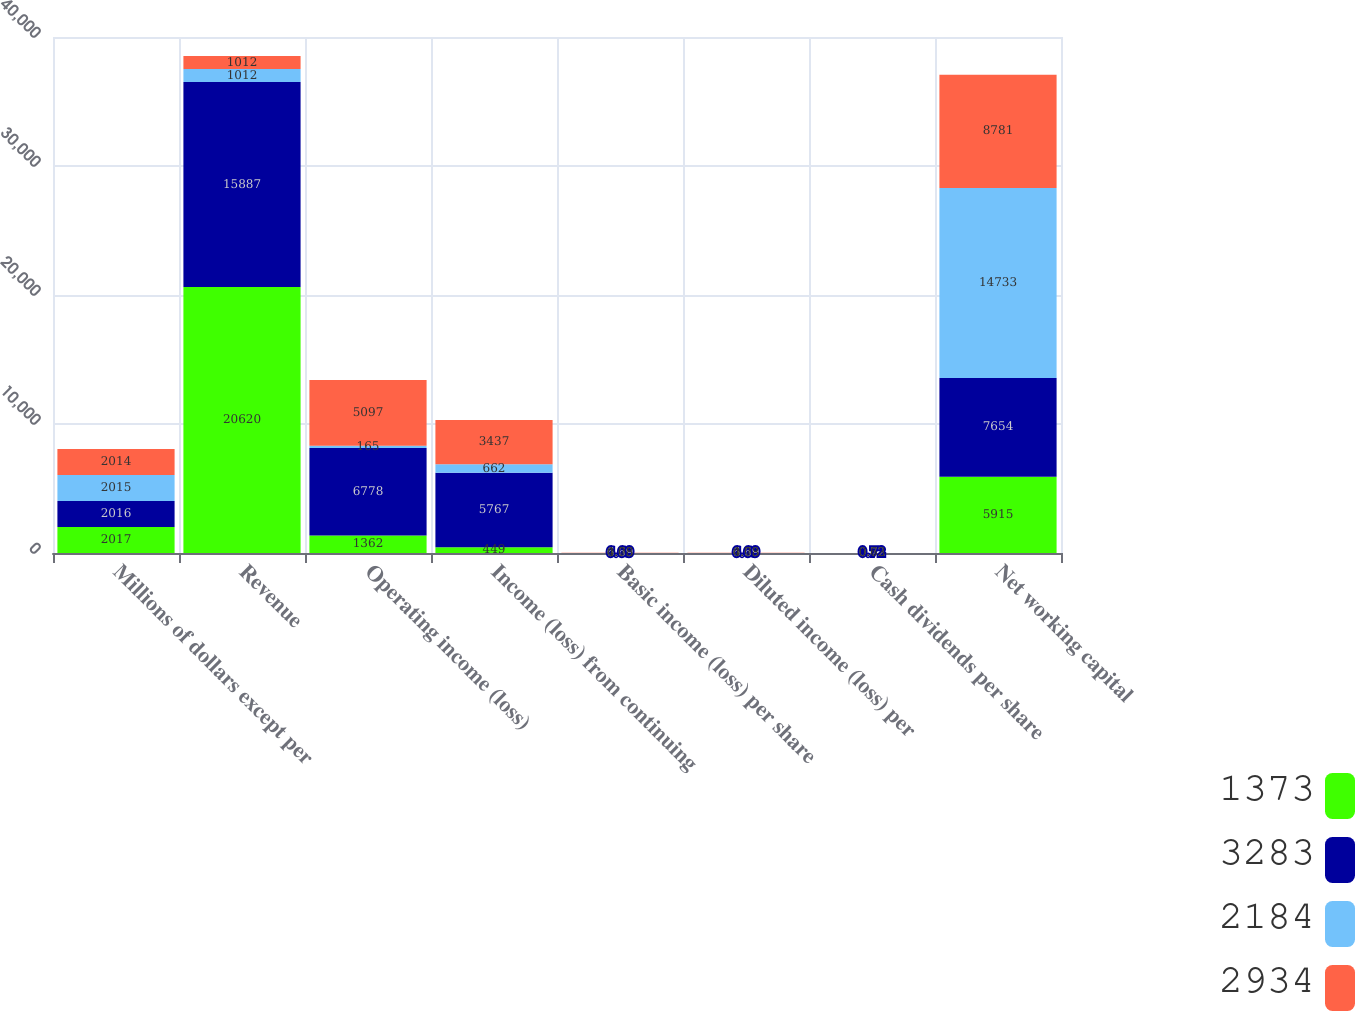<chart> <loc_0><loc_0><loc_500><loc_500><stacked_bar_chart><ecel><fcel>Millions of dollars except per<fcel>Revenue<fcel>Operating income (loss)<fcel>Income (loss) from continuing<fcel>Basic income (loss) per share<fcel>Diluted income (loss) per<fcel>Cash dividends per share<fcel>Net working capital<nl><fcel>1373<fcel>2017<fcel>20620<fcel>1362<fcel>449<fcel>0.51<fcel>0.51<fcel>0.72<fcel>5915<nl><fcel>3283<fcel>2016<fcel>15887<fcel>6778<fcel>5767<fcel>6.69<fcel>6.69<fcel>0.72<fcel>7654<nl><fcel>2184<fcel>2015<fcel>1012<fcel>165<fcel>662<fcel>0.78<fcel>0.78<fcel>0.72<fcel>14733<nl><fcel>2934<fcel>2014<fcel>1012<fcel>5097<fcel>3437<fcel>4.05<fcel>4.03<fcel>0.63<fcel>8781<nl></chart> 